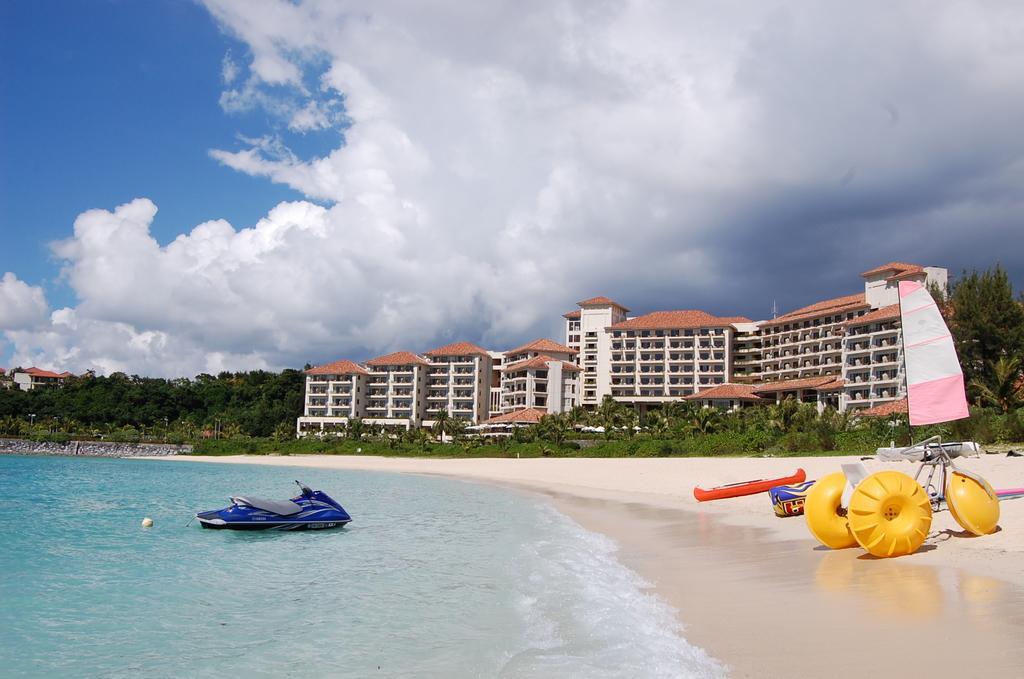Please provide a concise description of this image. In this image I can see water and in it I can see a blue colour jet ski. I can also see few boats, a water tricycle, number of trees, buildings, clouds and the sky. I can also see a pink and white colour thing over here. 